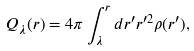<formula> <loc_0><loc_0><loc_500><loc_500>Q _ { \lambda } ( r ) = 4 \pi \int ^ { r } _ { \lambda } d r ^ { \prime } r ^ { \prime 2 } \rho ( r ^ { \prime } ) ,</formula> 